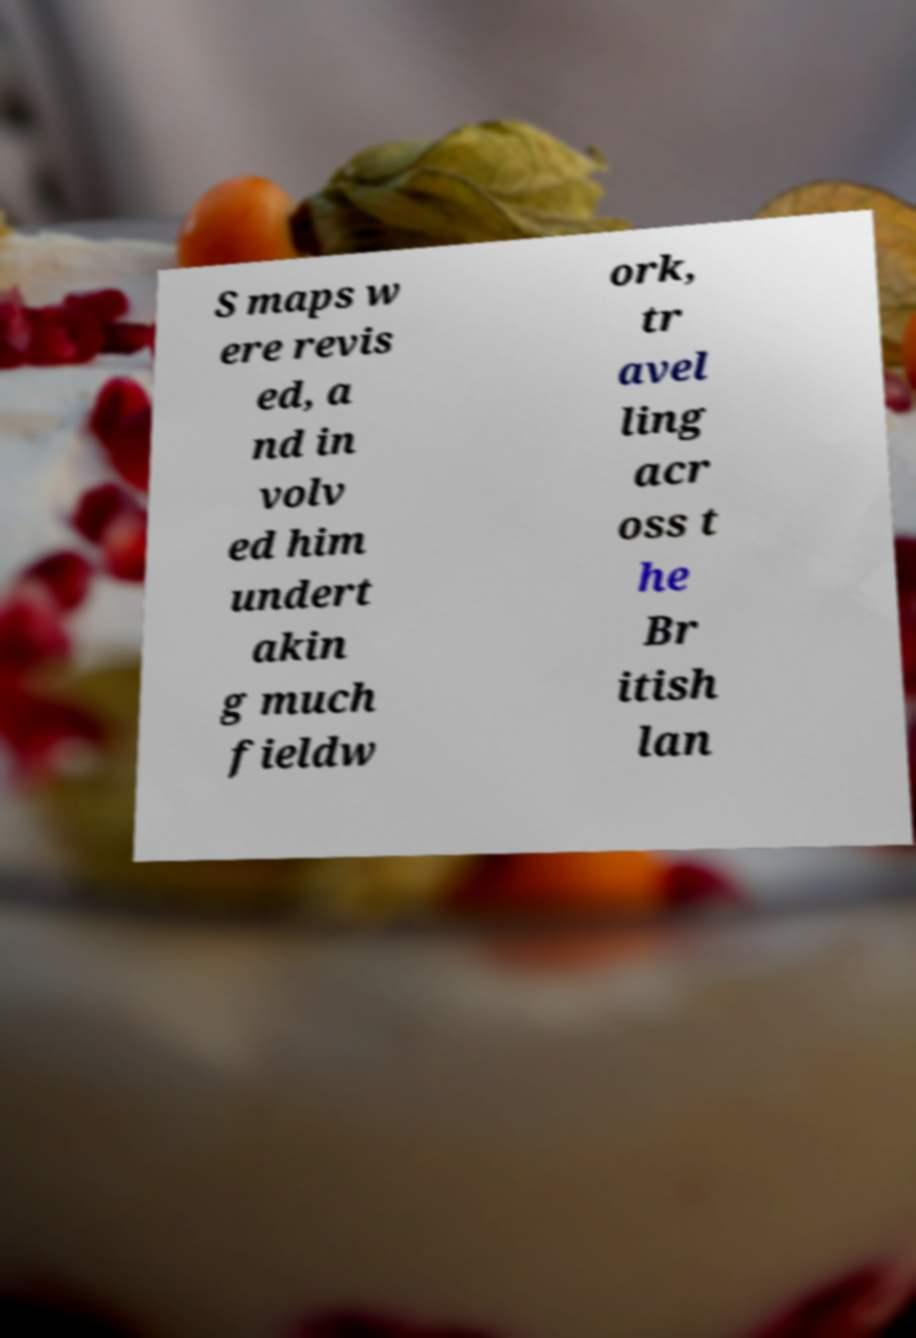Please identify and transcribe the text found in this image. S maps w ere revis ed, a nd in volv ed him undert akin g much fieldw ork, tr avel ling acr oss t he Br itish lan 